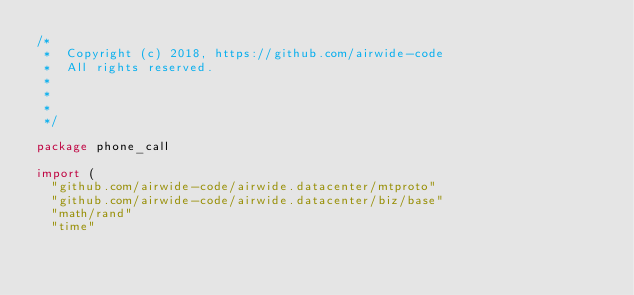<code> <loc_0><loc_0><loc_500><loc_500><_Go_>/*
 *  Copyright (c) 2018, https://github.com/airwide-code
 *  All rights reserved.
 *
 *
 *
 */

package phone_call

import (
	"github.com/airwide-code/airwide.datacenter/mtproto"
	"github.com/airwide-code/airwide.datacenter/biz/base"
	"math/rand"
	"time"</code> 